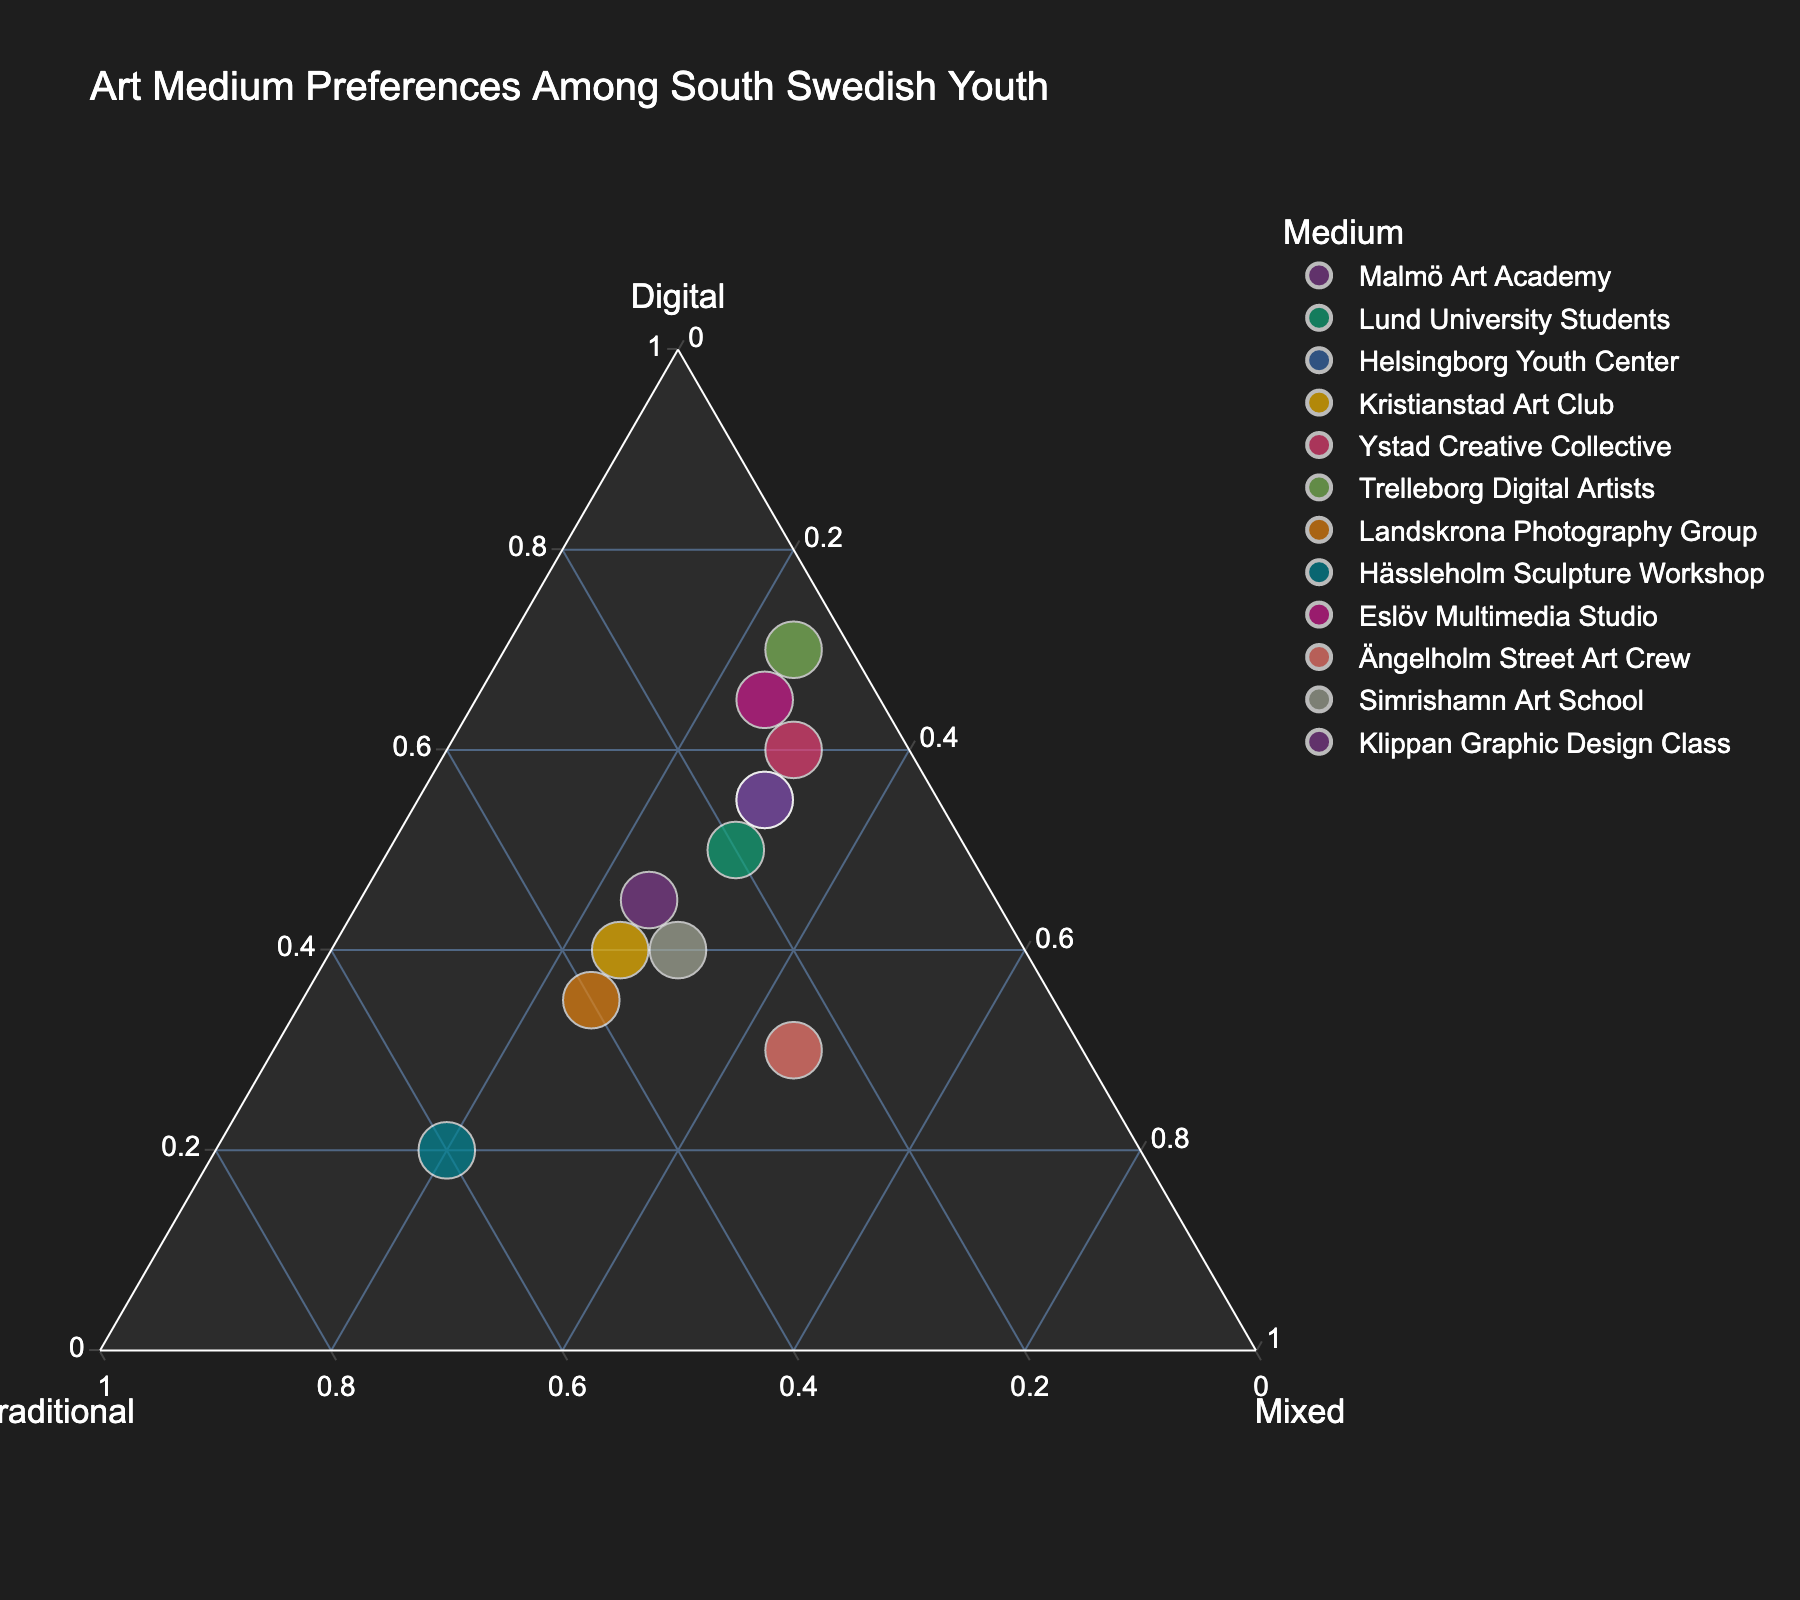What is the title of the figure? The title is placed at the top of the figure and provides an overview of what the plot represents. In this case, it tells us the plot is about art medium preferences among South Swedish youth.
Answer: Art Medium Preferences Among South Swedish Youth Which group has the highest preference for digital media? To find this, look at the plot for the data point closest to the vertex labeled 'Digital.' The closest point represents Trelleborg Digital Artists.
Answer: Trelleborg Digital Artists How does the preference for mixed media in Ängelholm Street Art Crew compare to Eslöv Multimedia Studio? To answer this, look at the positions of Ängelholm Street Art Crew and Eslöv Multimedia Studio on the 'Mixed' axis. Ängelholm Street Art Crew is higher on the 'Mixed' axis than Eslöv Multimedia Studio, indicating a higher preference for mixed media.
Answer: Ängelholm Street Art Crew has a higher preference for mixed media What is the average percentage of traditional media preference for Helsingborg Youth Center and Kristianstad Art Club? The traditional media preferences for Helsingborg Youth Center and Kristianstad Art Club are 15% and 35% respectively. The average is calculated as (15 + 35) / 2 = 25%.
Answer: 25% Are there any groups with equal preferences for digital, traditional, and mixed media? To find this, check if any data points are equidistant from all three vertices (Digital, Traditional, and Mixed). No points lie in the middle where all preferences are equal.
Answer: No Which group has the lowest preference for mixed media and how does it compare to the highest preference for mixed media? The lowest preference for mixed media is 20% (Hässleholm Sculpture Workshop), and the highest is 45% (Ängelholm Street Art Crew). The difference is 45% - 20% = 25%.
Answer: 25% How many groups have a digital media preference greater than 50%? Identify the points above the 50% marker on the 'Digital' axis. These are Trelleborg Digital Artists, Eslöv Multimedia Studio, and Klippan Graphic Design Class.
Answer: 3 What are the traditional media preferences for groups with the highest and lowest digital media preferences? The highest digital preference is 70% (Trelleborg Digital Artists) with 5% traditional, and the lowest is 20% (Hässleholm Sculpture Workshop) with 60% traditional.
Answer: 5% and 60% Which groups have a balanced (equal) preference for digital and traditional media? Check for data points where the values for Digital and Traditional are the same. No groups have equal values for these two media preferences.
Answer: None 